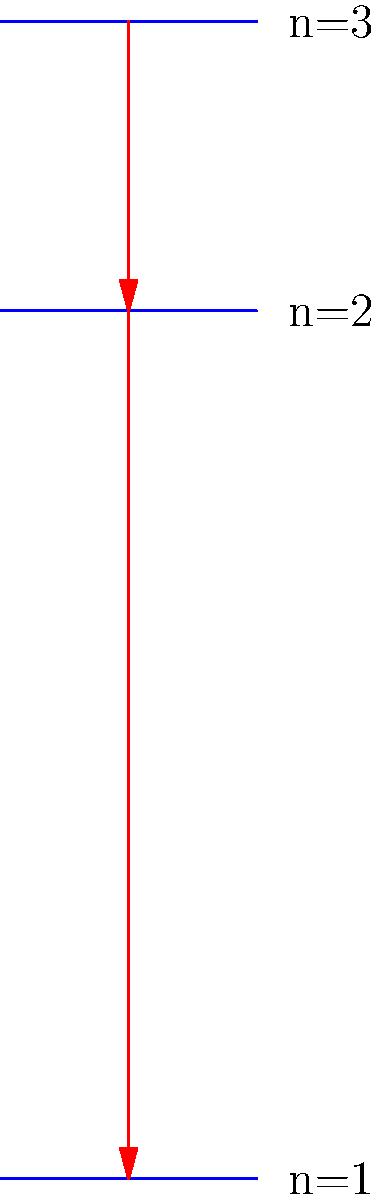In the context of immunofluorescence techniques used in immunology, consider the energy level diagram of a hydrogen atom shown above. Which series of spectral lines would be most relevant for fluorescence microscopy applications, and why? To answer this question, we need to consider the energy transitions and their corresponding wavelengths:

1. The diagram shows three energy levels of a hydrogen atom: n=1, n=2, and n=3.

2. The Lyman series involves transitions to the ground state (n=1):
   - n=2 to n=1: ΔE = 13.6 eV - 3.4 eV = 10.2 eV
   - n=3 to n=1: ΔE = 13.6 eV - 0 eV = 13.6 eV

3. The Balmer series involves transitions to the first excited state (n=2):
   - n=3 to n=2: ΔE = 3.4 eV - 0 eV = 3.4 eV

4. We can calculate the wavelengths using the formula: $E = hc/λ$
   - For Lyman series: λ ≈ 121.6 nm (for n=2 to n=1) and 91.2 nm (for n=3 to n=1)
   - For Balmer series: λ ≈ 364.7 nm (for n=3 to n=2)

5. Fluorescence microscopy typically uses visible or near-UV light:
   - Visible light range: 380-700 nm
   - Near-UV range: 300-400 nm

6. The Balmer series transition (364.7 nm) falls within the near-UV range, making it suitable for fluorescence microscopy.

7. The Lyman series transitions are in the far-UV range, which is not typically used in fluorescence microscopy due to potential damage to biological samples and limitations of optical components.

Therefore, the Balmer series would be most relevant for fluorescence microscopy applications in immunology.
Answer: Balmer series (near-UV, ~364.7 nm) 